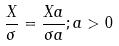<formula> <loc_0><loc_0><loc_500><loc_500>\frac { X } { \sigma } = \frac { X a } { \sigma a } ; a > 0</formula> 